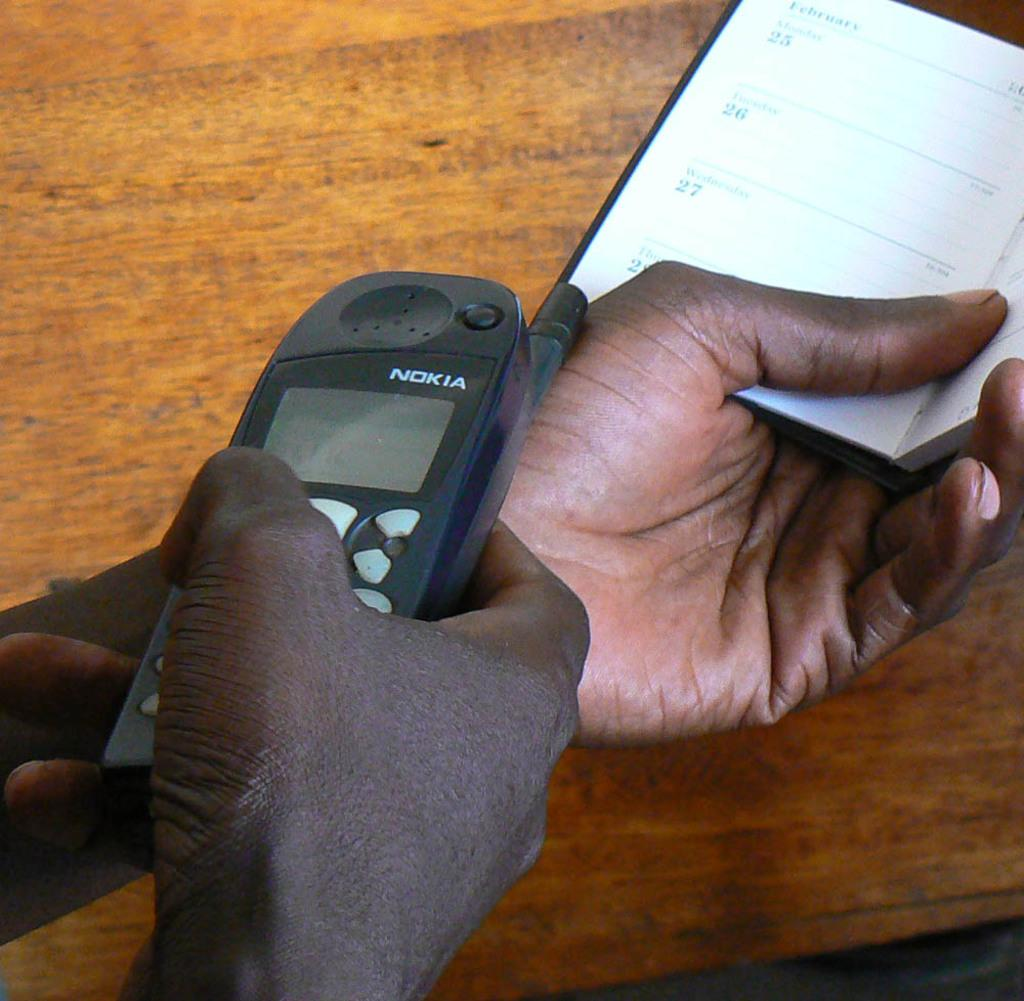<image>
Render a clear and concise summary of the photo. A man has a small calendar book in one hand and a Nokia phone in the other. 